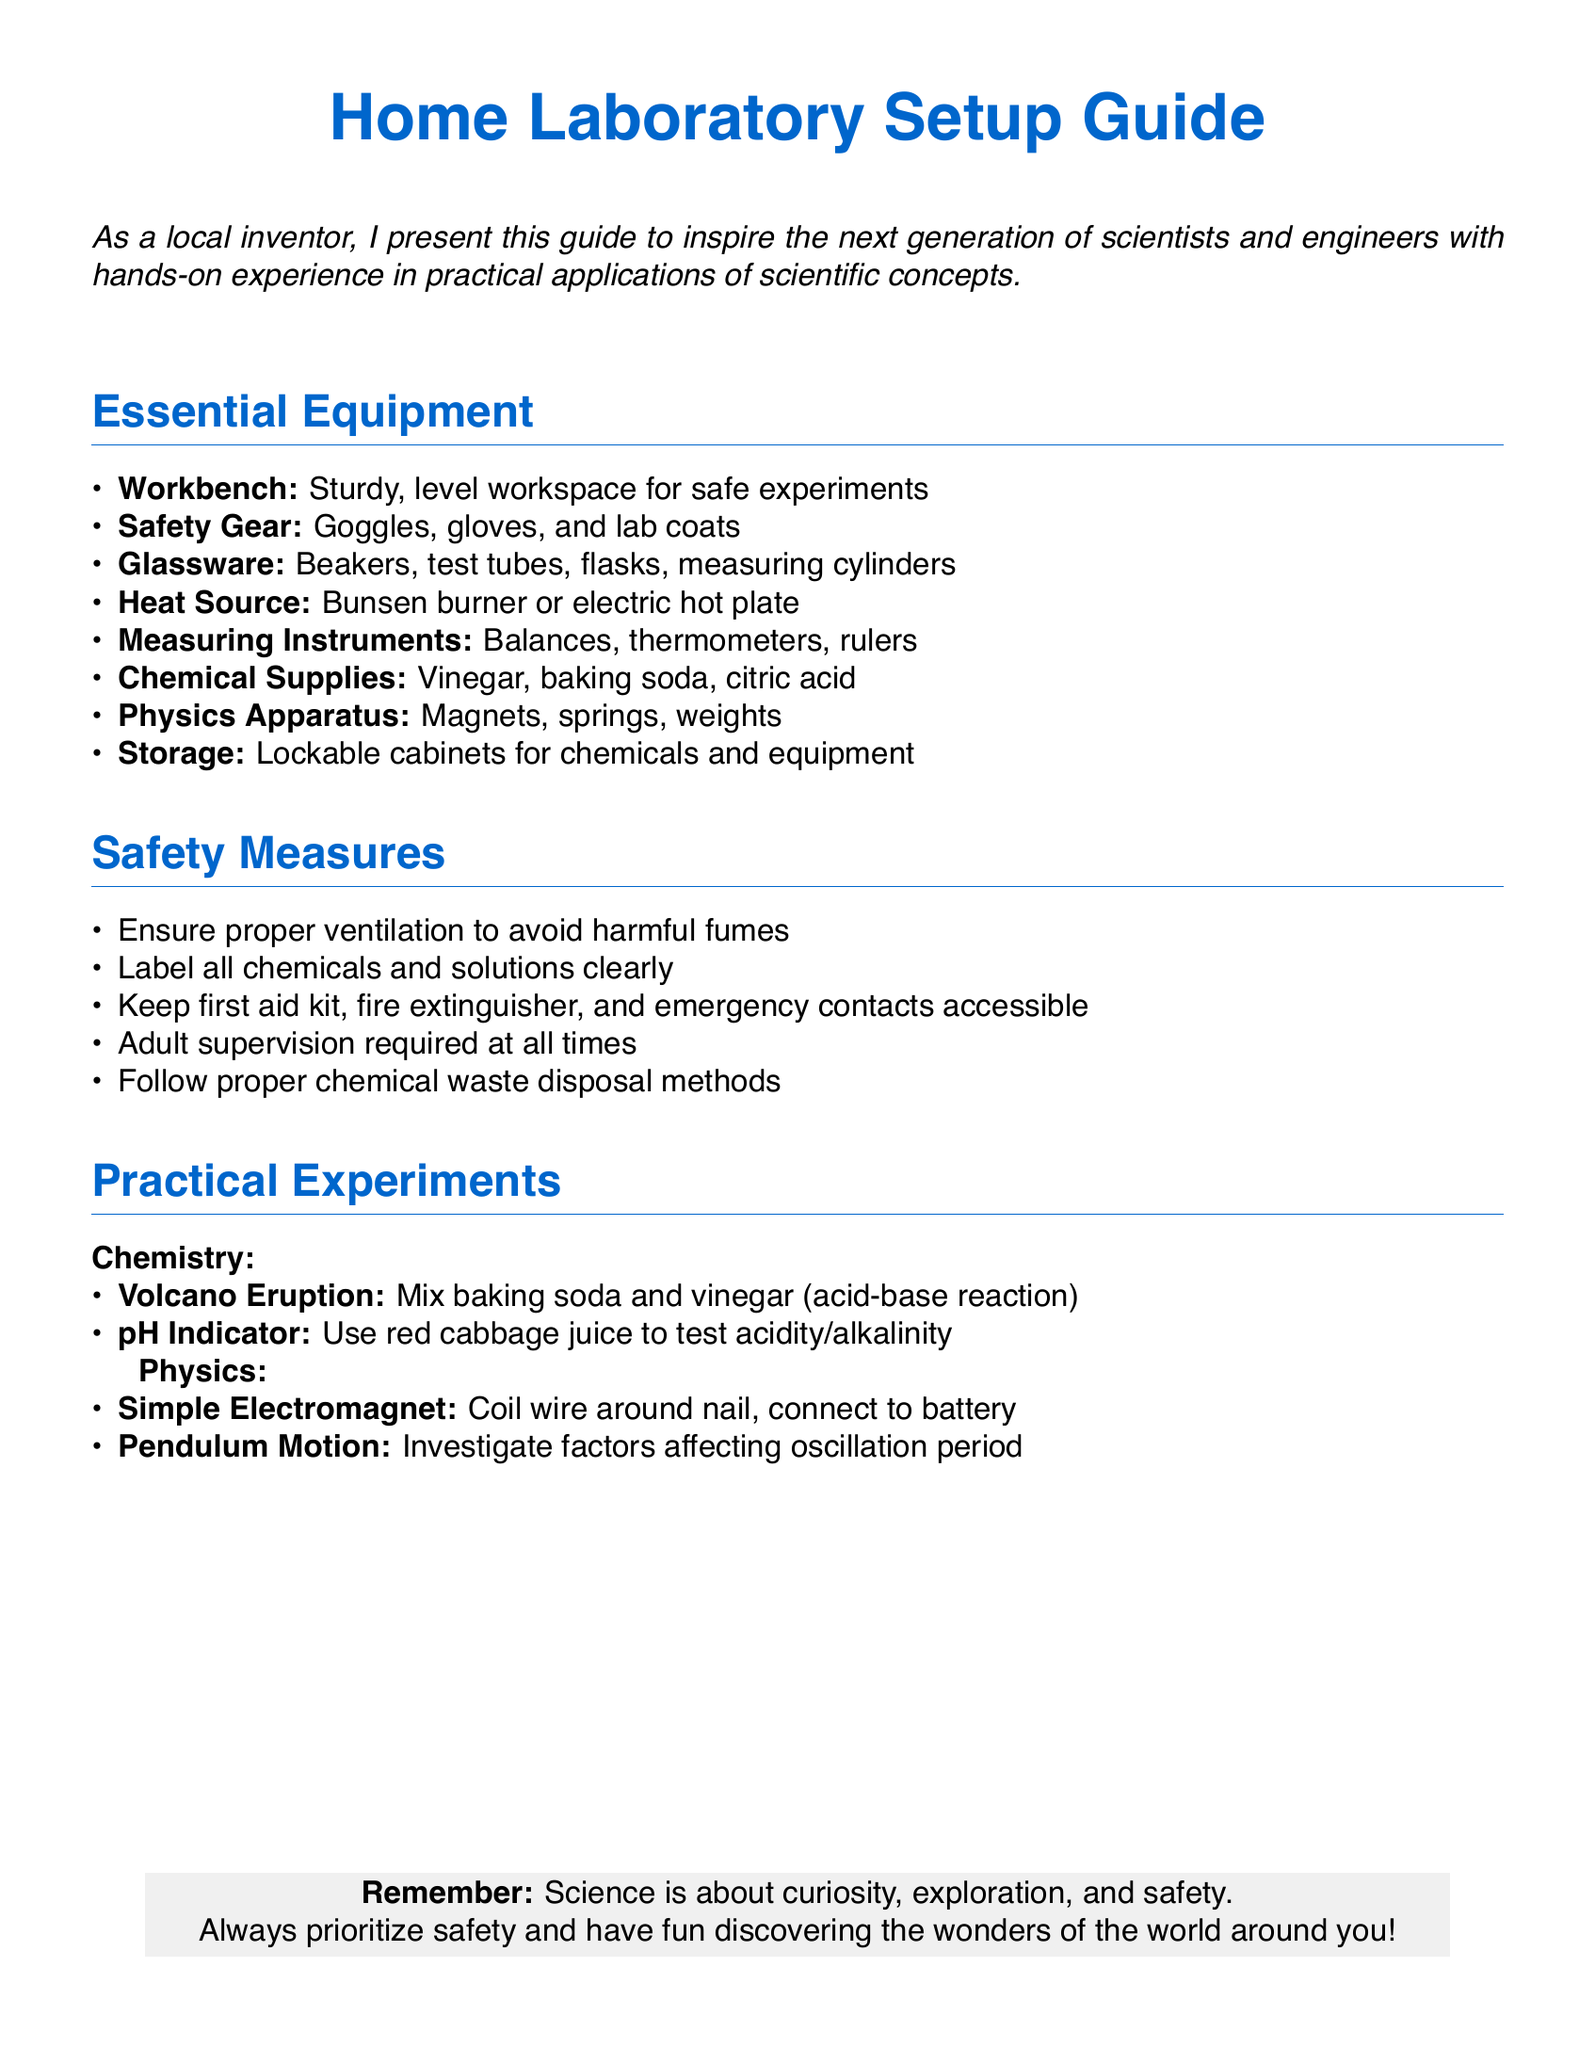What is the main purpose of the guide? The guide aims to inspire the next generation of scientists and engineers with hands-on experience in practical applications of scientific concepts.
Answer: To inspire teenagers What equipment is necessary for a home laboratory? The document lists essential equipment such as a sturdy workbench, safety gear, glassware, heat source, measuring instruments, chemical supplies, physics apparatus, and storage.
Answer: Workbench, safety gear, glassware, heat source, measuring instruments, chemical supplies, physics apparatus, storage What type of safety gear is recommended? The document specifies that goggles, gloves, and lab coats are important components of safety gear for the laboratory.
Answer: Goggles, gloves, lab coats What is an example of a chemistry experiment mentioned? The guide includes experiments such as the volcano eruption, which is a demonstration of an acid-base reaction using baking soda and vinegar.
Answer: Volcano Eruption How should chemicals be handled according to safety measures? Chemicals should be labeled clearly to ensure proper identification and safe handling in the laboratory.
Answer: Clearly labeled What should be kept accessible in the laboratory for emergencies? The guide states that a first aid kit, fire extinguisher, and emergency contacts should be accessible to handle potential emergencies.
Answer: First aid kit, fire extinguisher, emergency contacts What is one physics experiment that can be conducted? The document lists the simple electromagnet, where a wire is coiled around a nail and connected to a battery to create an electromagnet.
Answer: Simple Electromagnet What is emphasized at the end of the document? The guide stresses the importance of prioritizing safety and encourages exploration and discovery in science.
Answer: Safety and exploration 